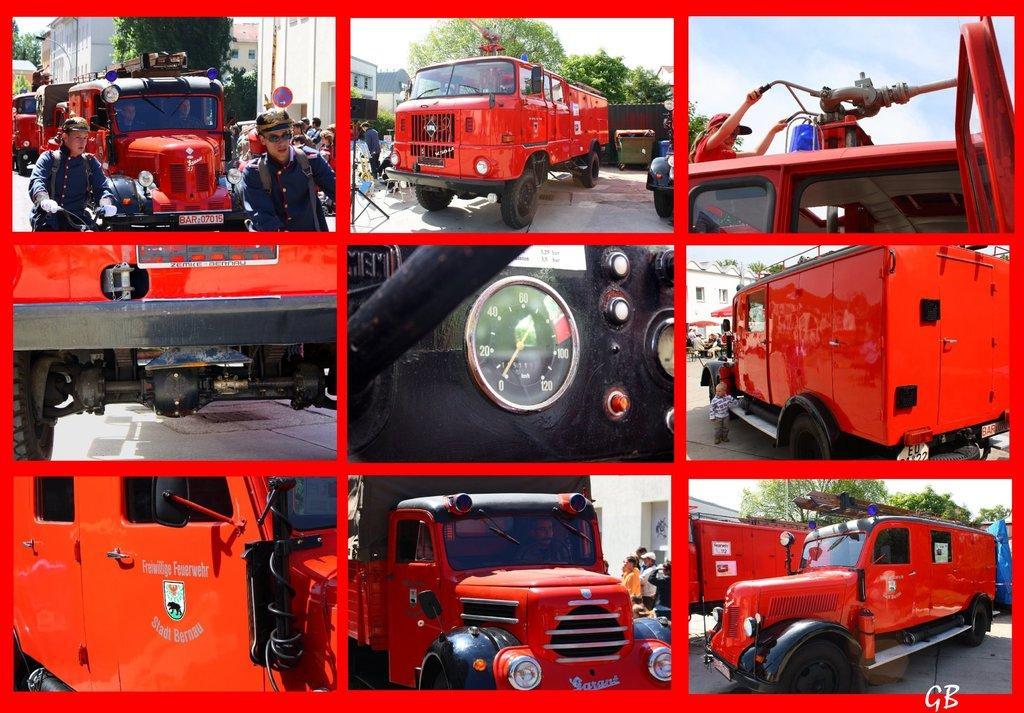Describe this image in one or two sentences. In this image there is a collage, there are persons riding a motorcycle, there are vehicles on the road, there is a board, there are buildings truncated towards the top of the image, there are trees truncated towards the top of the image, there are objects on the ground, there is an inside view of a vehicle, there is the sky truncated towards the top of the image, there is text on the vehicle, there is text towards the bottom of the image, there is the wall, there is an object truncated towards the right of the image, there is an object truncated towards the left of the image, there are vehicles truncated towards the bottom of the image. 